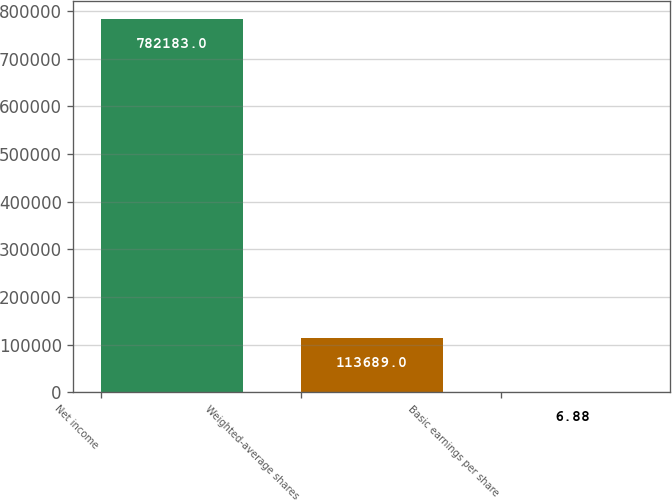<chart> <loc_0><loc_0><loc_500><loc_500><bar_chart><fcel>Net income<fcel>Weighted-average shares<fcel>Basic earnings per share<nl><fcel>782183<fcel>113689<fcel>6.88<nl></chart> 